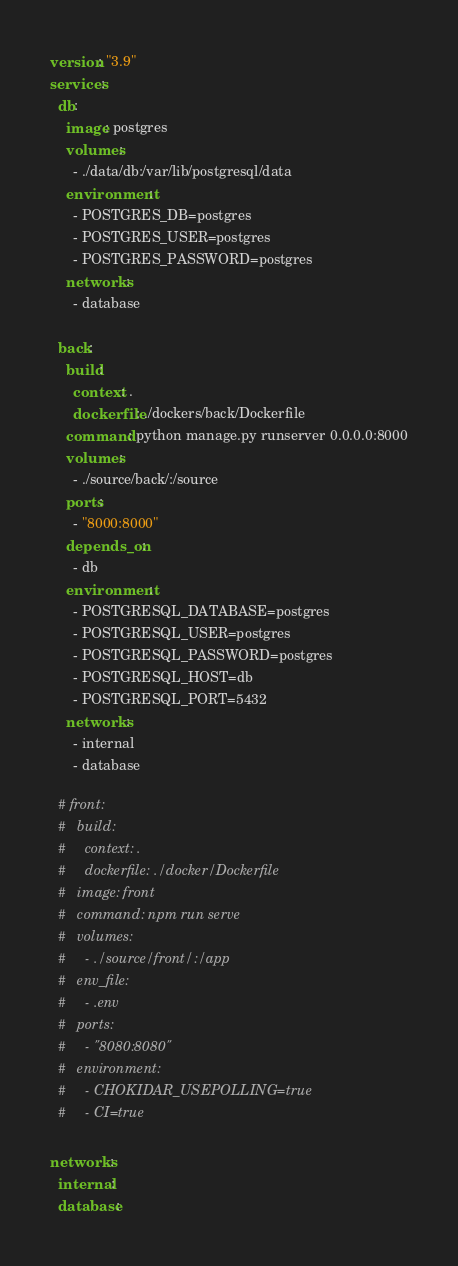Convert code to text. <code><loc_0><loc_0><loc_500><loc_500><_YAML_>version: "3.9"
services:
  db:
    image: postgres
    volumes:
      - ./data/db:/var/lib/postgresql/data
    environment:
      - POSTGRES_DB=postgres
      - POSTGRES_USER=postgres
      - POSTGRES_PASSWORD=postgres
    networks:
      - database

  back:
    build:
      context: .
      dockerfile: ./dockers/back/Dockerfile
    command: python manage.py runserver 0.0.0.0:8000
    volumes:
      - ./source/back/:/source
    ports:
      - "8000:8000"
    depends_on:
      - db
    environment:
      - POSTGRESQL_DATABASE=postgres
      - POSTGRESQL_USER=postgres
      - POSTGRESQL_PASSWORD=postgres
      - POSTGRESQL_HOST=db
      - POSTGRESQL_PORT=5432
    networks:
      - internal
      - database

  # front:
  #   build:
  #     context: .
  #     dockerfile: ./docker/Dockerfile
  #   image: front
  #   command: npm run serve
  #   volumes:
  #     - ./source/front/:/app
  #   env_file:
  #     - .env
  #   ports:
  #     - "8080:8080"
  #   environment: 
  #     - CHOKIDAR_USEPOLLING=true
  #     - CI=true
    
networks:
  internal:
  database:</code> 